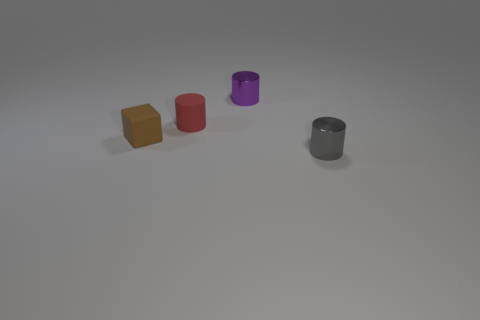Is there any other thing that is the same shape as the small brown rubber thing?
Your answer should be very brief. No. How many cyan cylinders are there?
Your answer should be compact. 0. Are there any rubber cubes of the same size as the brown rubber thing?
Your answer should be very brief. No. Does the brown thing have the same material as the red object that is in front of the purple shiny thing?
Ensure brevity in your answer.  Yes. There is a small block that is in front of the tiny red thing; what is it made of?
Your response must be concise. Rubber. There is a gray cylinder in front of the tiny purple cylinder; does it have the same size as the purple cylinder right of the small matte block?
Your answer should be compact. Yes. There is a matte object that is the same shape as the gray metallic object; what is its size?
Your answer should be compact. Small. There is a metallic cylinder that is right of the purple cylinder; is there a purple cylinder that is in front of it?
Provide a succinct answer. No. There is a small rubber object that is right of the cube; what shape is it?
Provide a succinct answer. Cylinder. There is a tiny cylinder that is to the left of the small metallic thing behind the small brown object; what is its color?
Ensure brevity in your answer.  Red. 